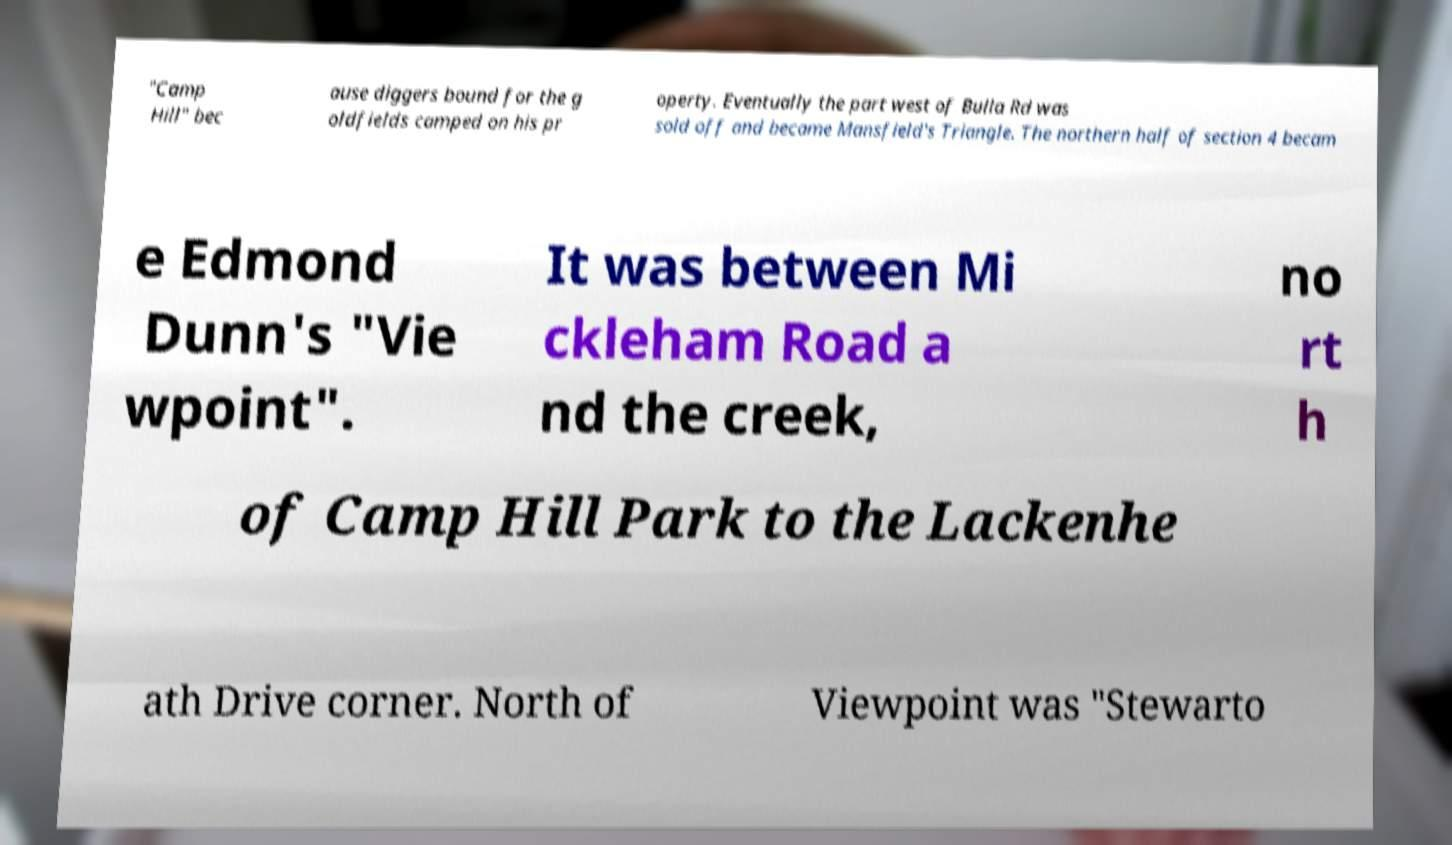For documentation purposes, I need the text within this image transcribed. Could you provide that? "Camp Hill" bec ause diggers bound for the g oldfields camped on his pr operty. Eventually the part west of Bulla Rd was sold off and became Mansfield's Triangle. The northern half of section 4 becam e Edmond Dunn's "Vie wpoint". It was between Mi ckleham Road a nd the creek, no rt h of Camp Hill Park to the Lackenhe ath Drive corner. North of Viewpoint was "Stewarto 